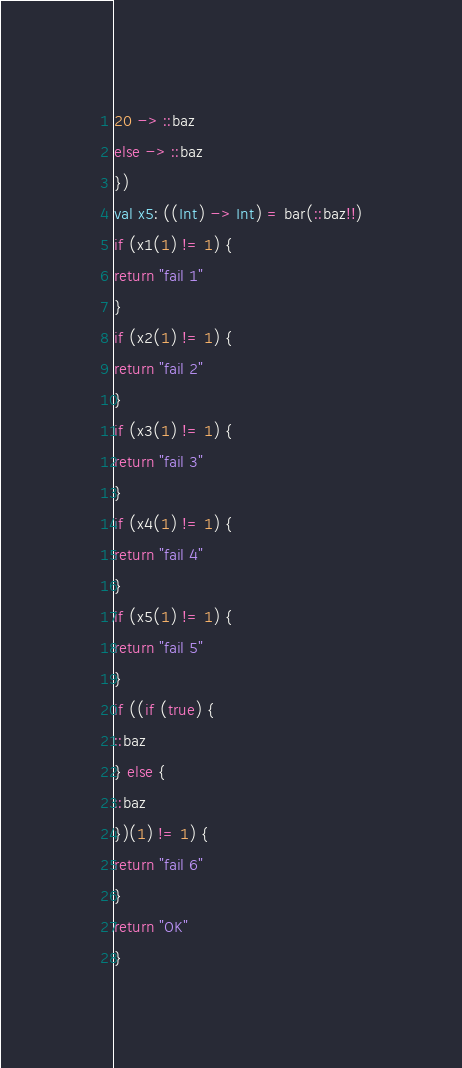Convert code to text. <code><loc_0><loc_0><loc_500><loc_500><_Kotlin_>20 -> ::baz
else -> ::baz
})
val x5: ((Int) -> Int) = bar(::baz!!)
if (x1(1) != 1) {
return "fail 1"
}
if (x2(1) != 1) {
return "fail 2"
}
if (x3(1) != 1) {
return "fail 3"
}
if (x4(1) != 1) {
return "fail 4"
}
if (x5(1) != 1) {
return "fail 5"
}
if ((if (true) {
::baz
} else {
::baz
})(1) != 1) {
return "fail 6"
}
return "OK"
}</code> 